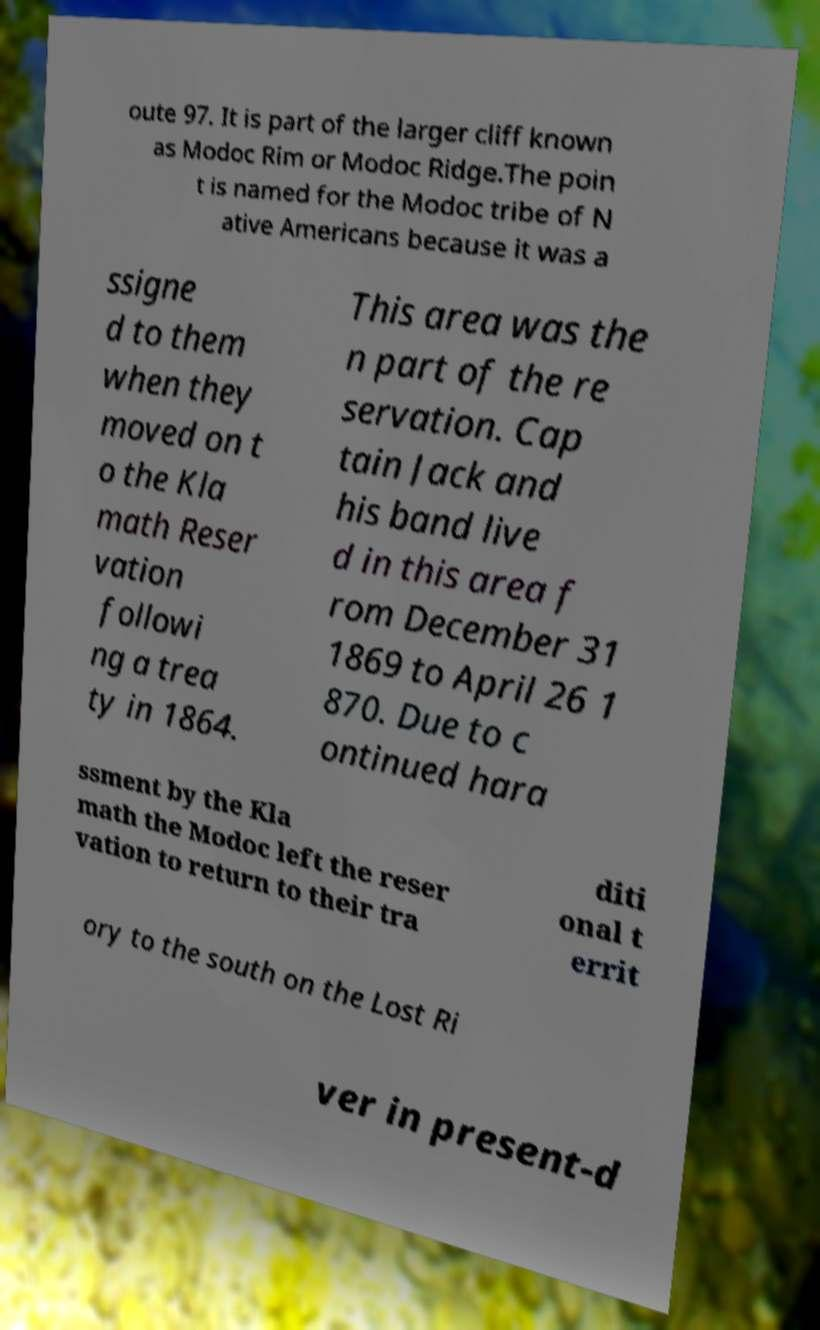Please identify and transcribe the text found in this image. oute 97. It is part of the larger cliff known as Modoc Rim or Modoc Ridge.The poin t is named for the Modoc tribe of N ative Americans because it was a ssigne d to them when they moved on t o the Kla math Reser vation followi ng a trea ty in 1864. This area was the n part of the re servation. Cap tain Jack and his band live d in this area f rom December 31 1869 to April 26 1 870. Due to c ontinued hara ssment by the Kla math the Modoc left the reser vation to return to their tra diti onal t errit ory to the south on the Lost Ri ver in present-d 